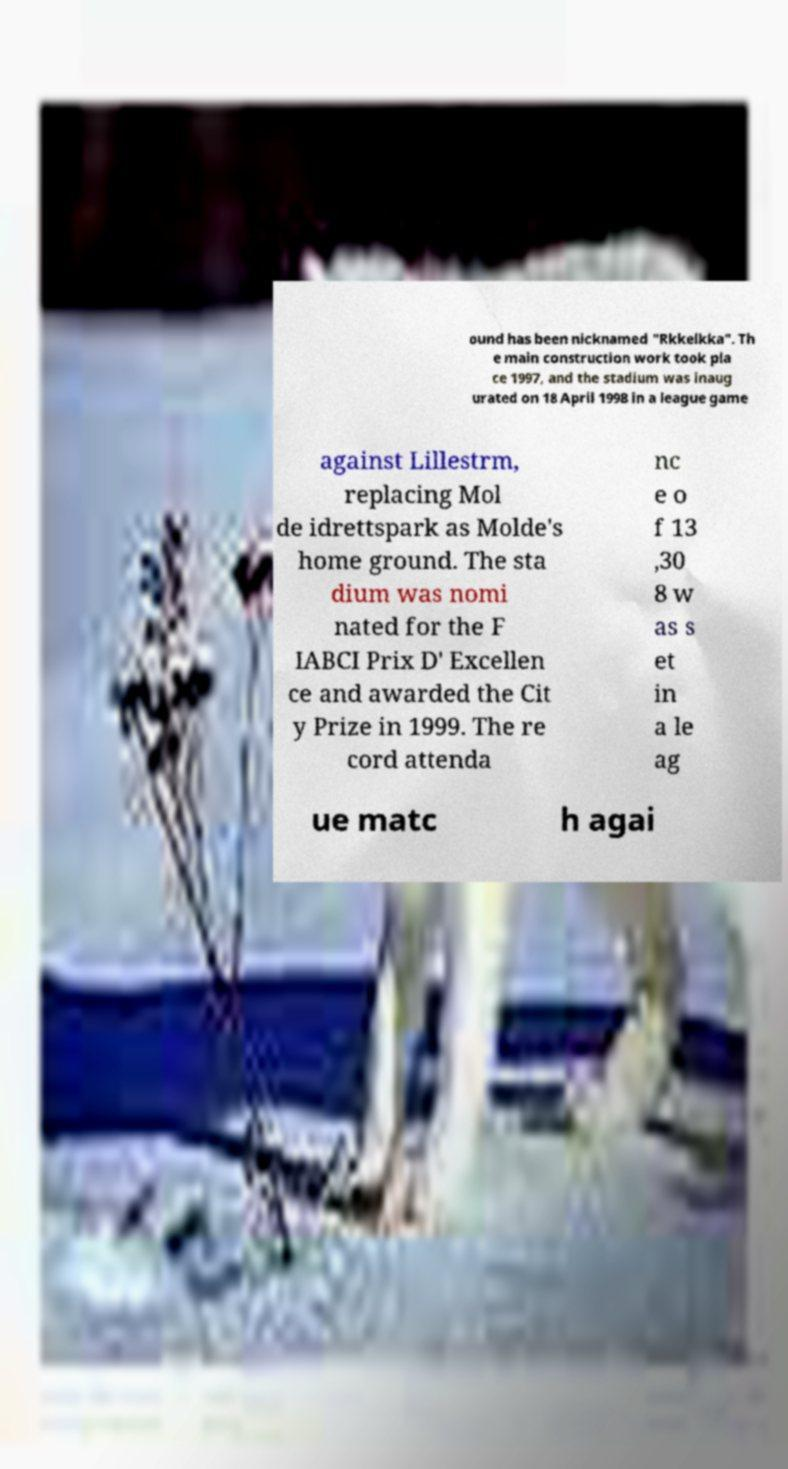Could you extract and type out the text from this image? ound has been nicknamed "Rkkelkka". Th e main construction work took pla ce 1997, and the stadium was inaug urated on 18 April 1998 in a league game against Lillestrm, replacing Mol de idrettspark as Molde's home ground. The sta dium was nomi nated for the F IABCI Prix D' Excellen ce and awarded the Cit y Prize in 1999. The re cord attenda nc e o f 13 ,30 8 w as s et in a le ag ue matc h agai 